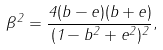<formula> <loc_0><loc_0><loc_500><loc_500>\beta ^ { 2 } = \frac { 4 ( b - e ) ( b + e ) } { ( 1 - b ^ { 2 } + e ^ { 2 } ) ^ { 2 } } ,</formula> 